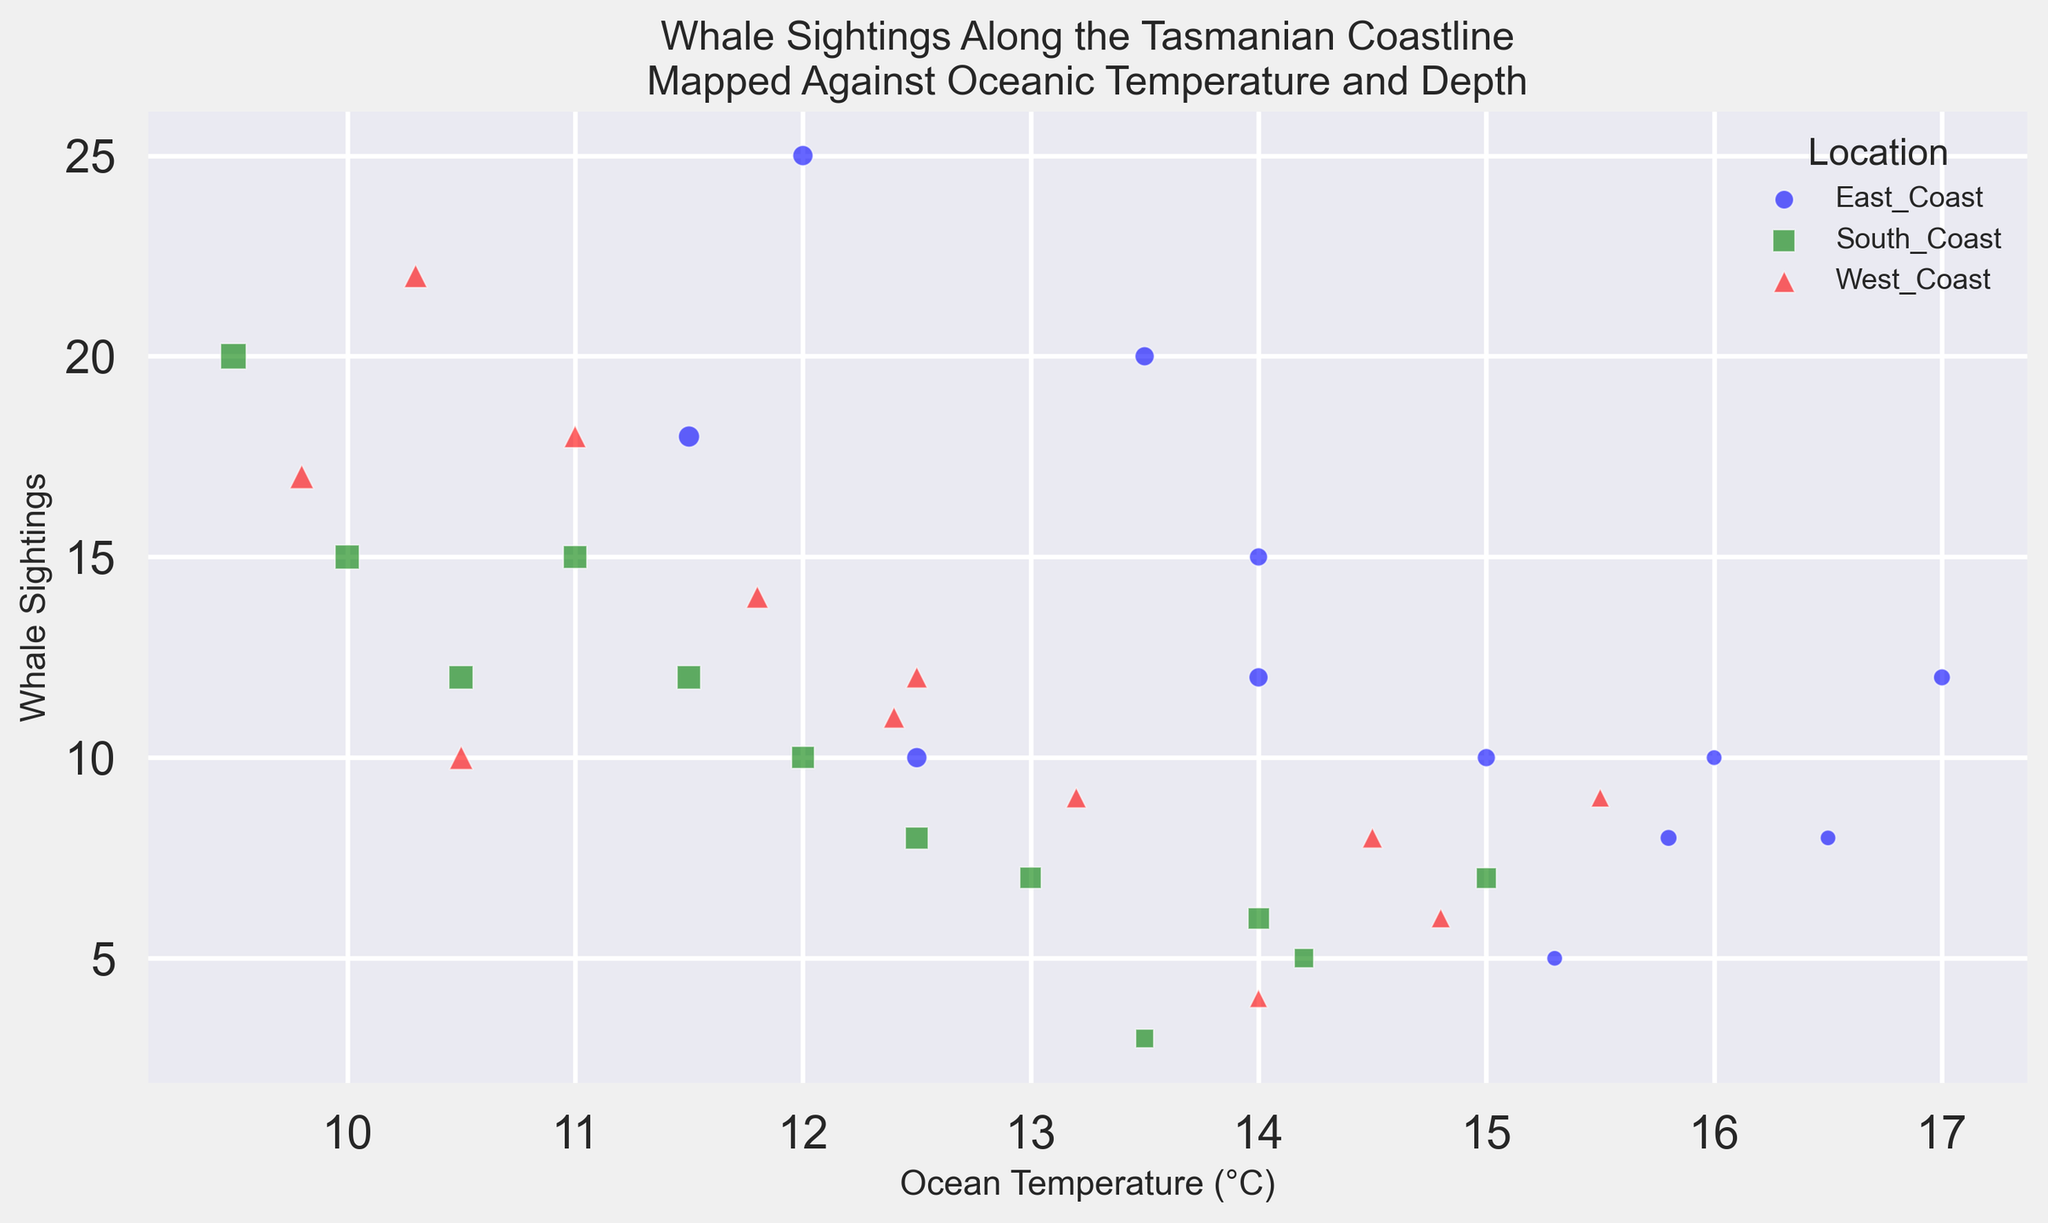Which location had the most whale sightings when the ocean temperature was at its lowest? For the East Coast, the lowest temperature is 11.5°C in August with 18 sightings. For the South Coast, the lowest temperature is 9.5°C in August with 20 sightings. For the West Coast, the lowest temperature is 9.8°C in August with 17 sightings. So, the South Coast had the most sightings at its lowest temperature.
Answer: South Coast Which month shows the highest whale sightings overall? From the scatter plot, identify the data points with the highest y-values. Highest whale sightings (y-label) are in July for East Coast (25 sightings), August for South Coast (20 sightings), and July for West Coast (22 sightings). The East Coast in July shows the highest whale sightings.
Answer: July What is the average number of whale sightings in October for all locations? October whale sightings are 12 for East Coast, 15 for South Coast, and 14 for West Coast. Sum these sightings: 12 + 15 + 14 = 41. The average is 41 / 3 = 13.67.
Answer: 13.67 How is the whale sighting related to ocean depth for the East Coast? Look for the size (s) of the markers on the East Coast data points. Larger markers indicate greater ocean depths. Whale sightings peak at depths of 50 units (July, with 25 sightings).
Answer: Peak sightings at greater depths Which location had a whale sighting when the ocean temperature was highest? Find the highest x-value (ocean temperature) data point for each location. For East Coast, highest temperature 17.0°C (March, 12 sightings). For South Coast, highest temperature 15.0°C (March, 7 sightings). For West Coast, highest temperature 15.5°C (March, 9 sightings).
Answer: East Coast Do colder ocean temperatures correlate with higher whale sightings? Compare scatter points from all locations; visually, whale sightings are higher when the temperature decreases, particularly from June to August across locations.
Answer: Yes Which month shows the least whale sightings across all locations? Identify the lowest y-values (whale sightings). For East Coast, South Coast, and West Coast, the lowest monthly sightings occur in January for East (5), South (3), and West (4). Least sightings overall are in January for the South Coast.
Answer: January Between May and September, which coast had the highest number of sightings? Sum sighting numbers between May and September for each location: East Coast (15+20+25+18+10 = 88), South Coast (10+12+15+20+12 = 69), and West Coast (12+18+22+17+10 = 79). East Coast has the highest.
Answer: East Coast 